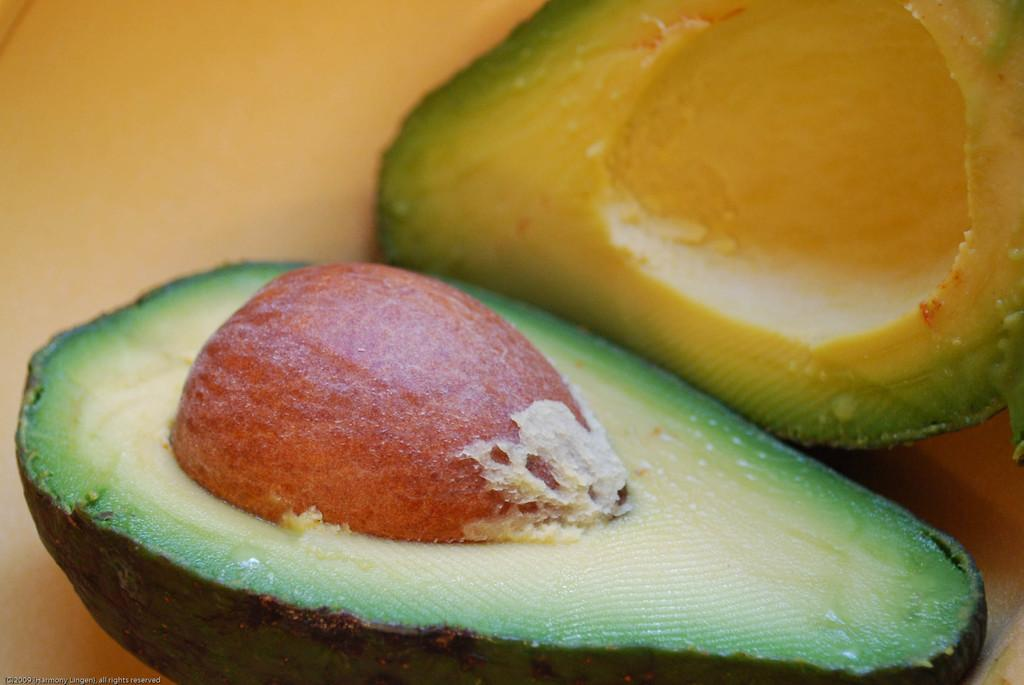What is the main subject of the image? The main subject of the image is an avocado. How is the avocado presented in the image? The avocado is cut into two pieces in the image. What can be seen inside the avocado? There is a seed visible in the avocado. How many members are on the team that is visible in the image? There is no team present in the image; it features an avocado cut into two pieces with a visible seed. What type of cast can be seen on the avocado in the image? There is no cast present on the avocado in the image; it is simply cut into two pieces with a visible seed. 